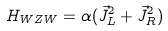<formula> <loc_0><loc_0><loc_500><loc_500>H _ { W Z W } = \alpha ( \vec { J } _ { L } ^ { 2 } + \vec { J } _ { R } ^ { 2 } )</formula> 